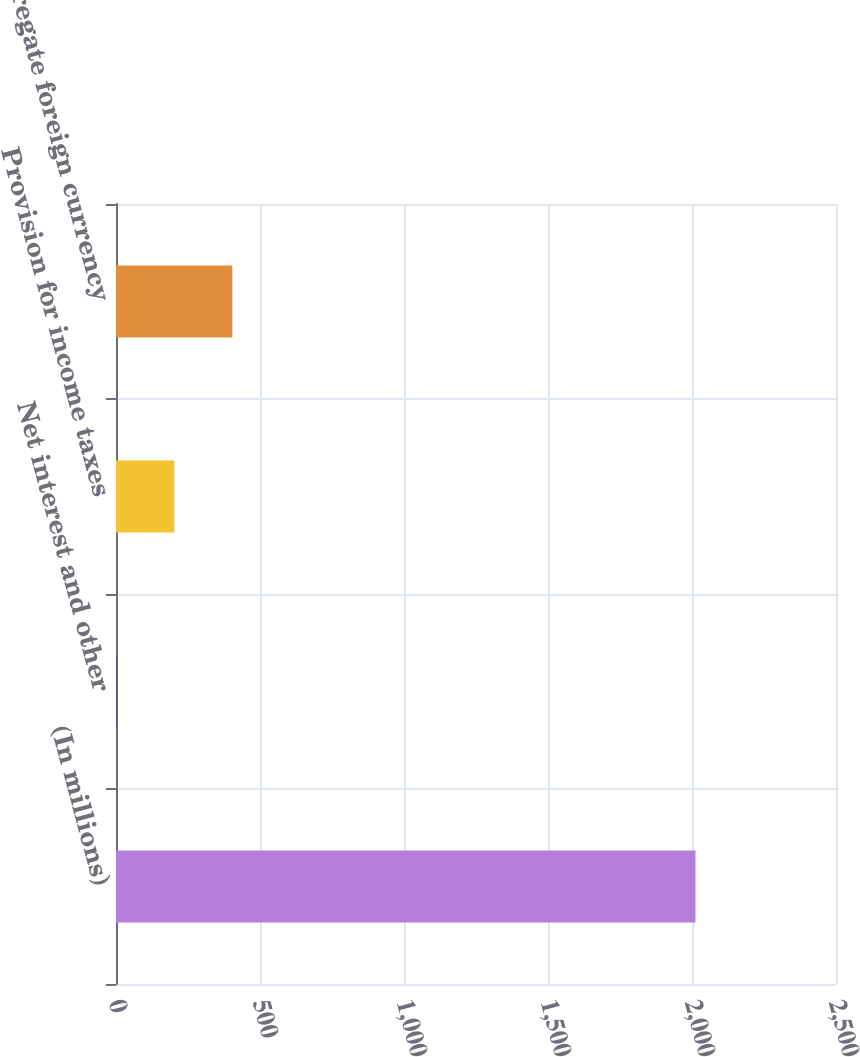<chart> <loc_0><loc_0><loc_500><loc_500><bar_chart><fcel>(In millions)<fcel>Net interest and other<fcel>Provision for income taxes<fcel>Aggregate foreign currency<nl><fcel>2012<fcel>2<fcel>203<fcel>404<nl></chart> 